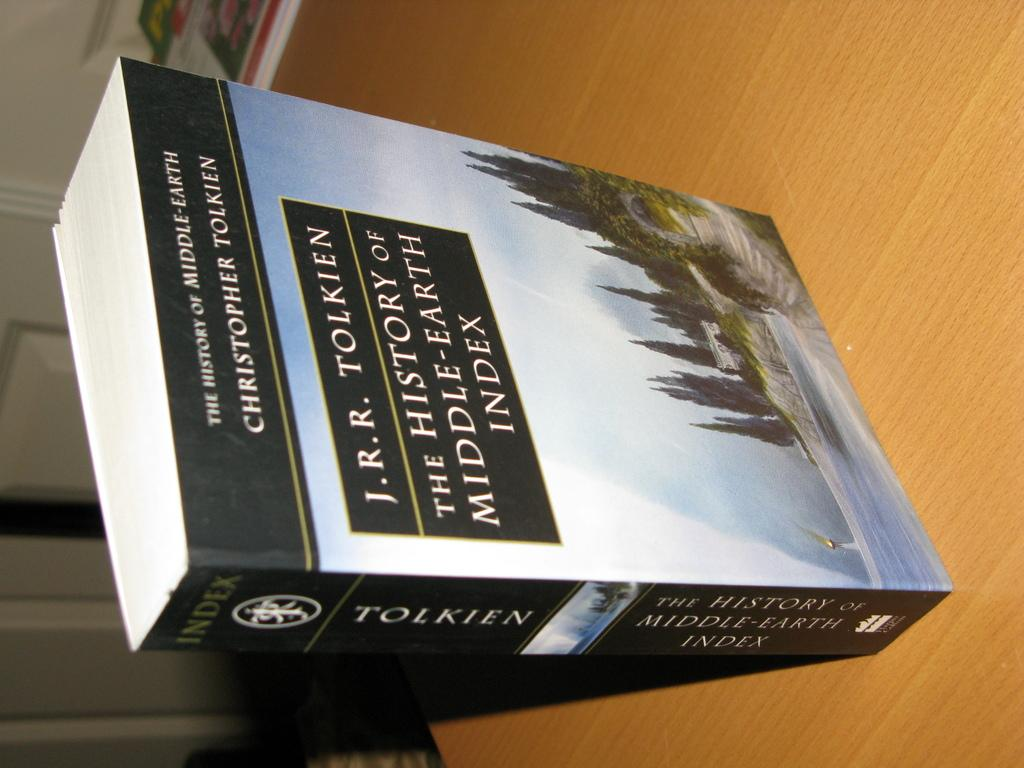<image>
Render a clear and concise summary of the photo. J.R.R. Tolkien's "The History of Middle-Earth Index" is available in paperback. 